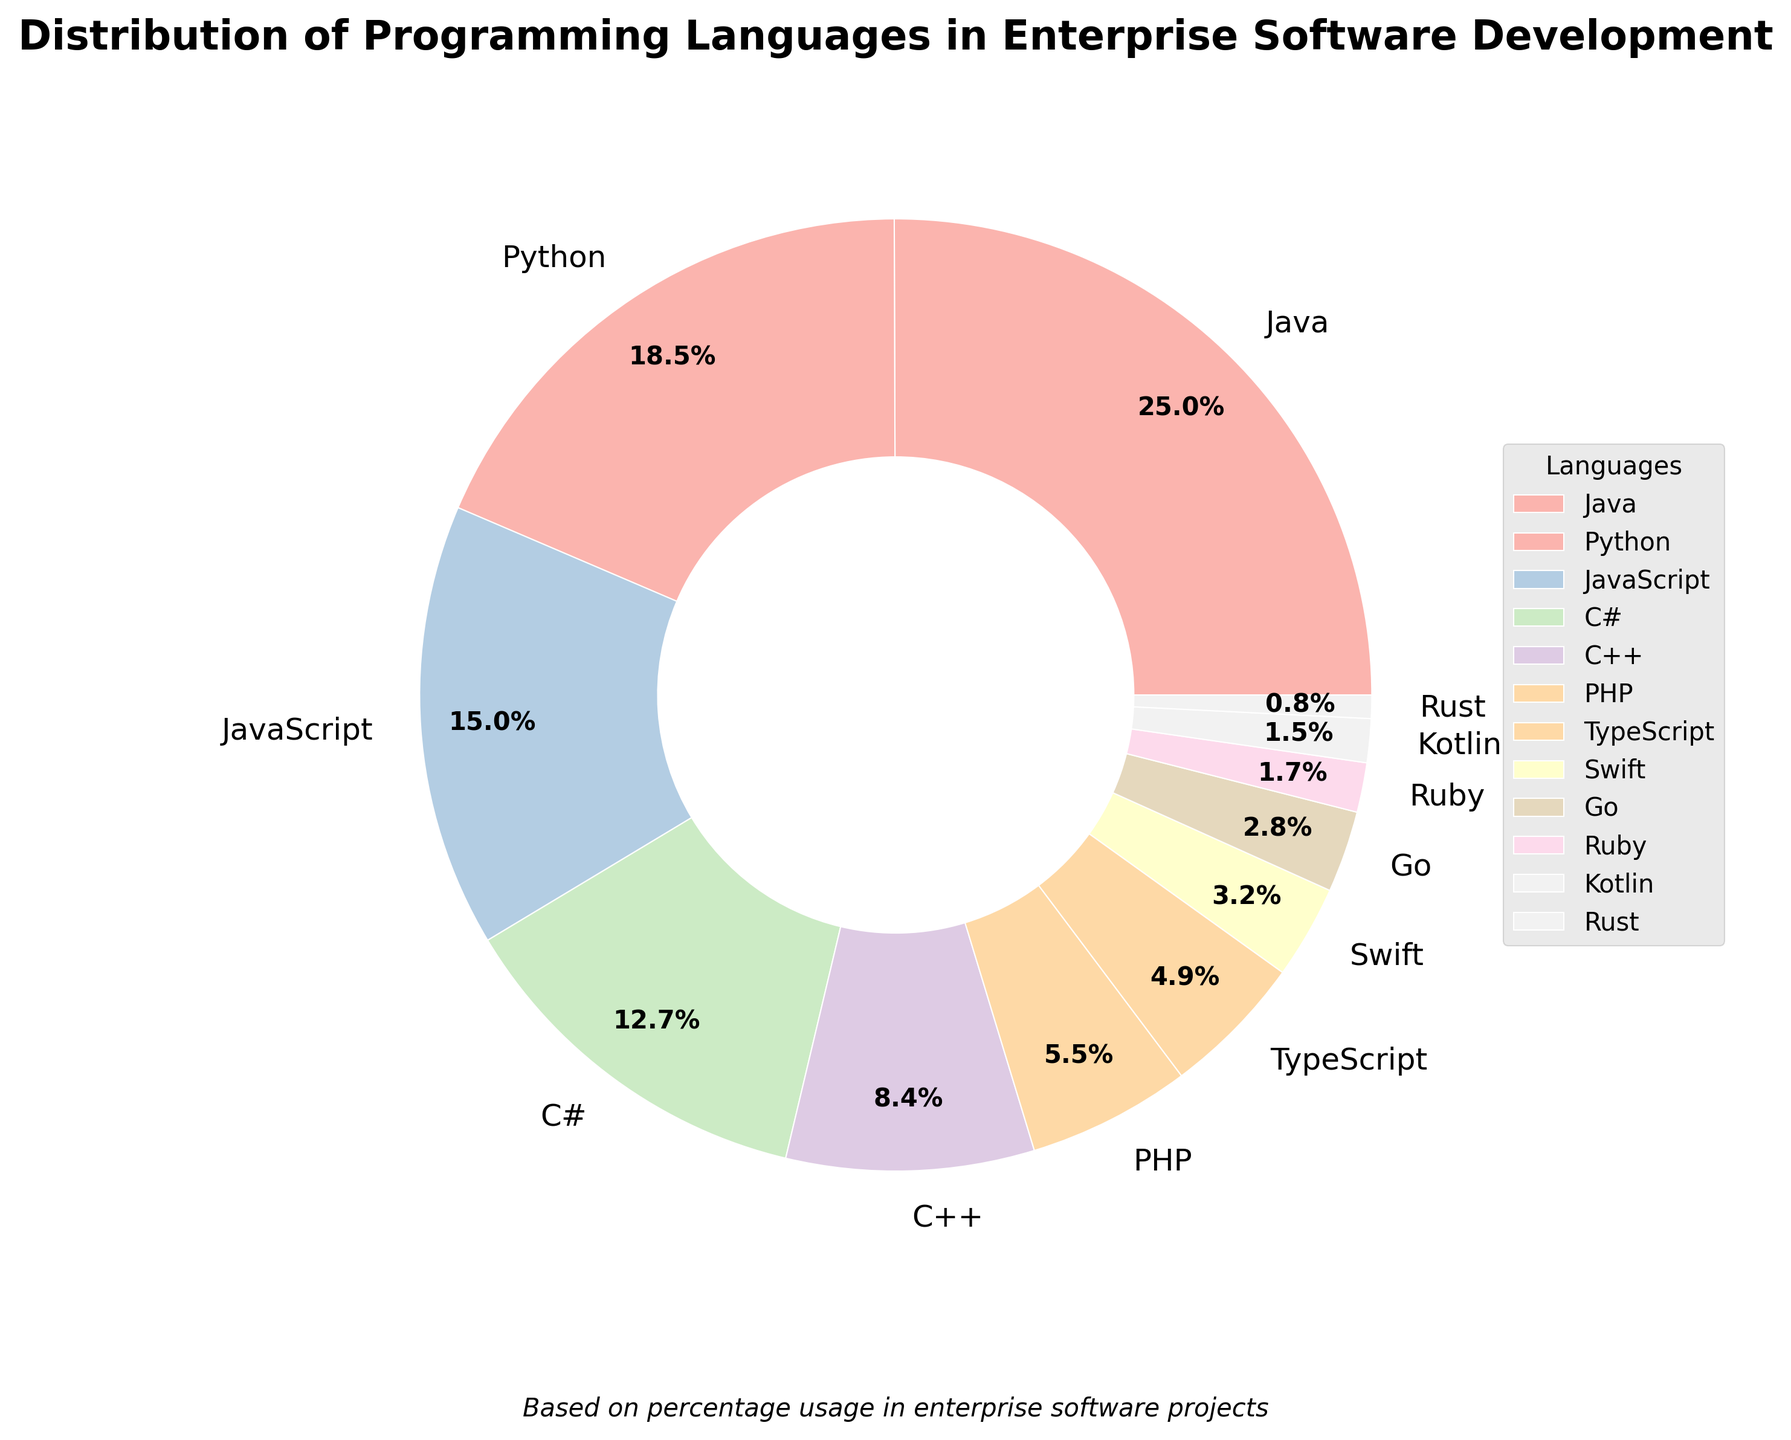Which programming language has the highest usage in enterprise software development based on the pie chart? Java has the highest percentage in the pie chart at 25.3%, thus it is the most used programming language in enterprise software development.
Answer: Java What is the combined percentage usage of Python and JavaScript in enterprise software development? Python has a percentage of 18.7% and JavaScript has 15.2%. Adding these together gives 18.7% + 15.2% = 33.9%.
Answer: 33.9% How much more popular is Java compared to Kotlin based on the pie chart? Java has a percentage of 25.3%, while Kotlin has 1.5%. The difference is 25.3% - 1.5% = 23.8%.
Answer: 23.8% Which two programming languages combined have a higher usage than C# but lower than Java? The percentage for C# is 12.8%. The combined percentages that are higher than 12.8% but less than Java's 25.3% are Python (18.7%) and JavaScript (15.2%), which equal 18.7% + 15.2% = 33.9%.
Answer: Python and JavaScript Among the following programming languages: C#, PHP, and Ruby, which one has the lowest usage in enterprise software development? From the pie chart, C# has 12.8%, PHP has 5.6%, and Ruby has 1.7%. Therefore, Ruby has the lowest usage.
Answer: Ruby If you combine the percentage usage of Swift and Go, what percentage do you get? Swift has a percentage of 3.2% and Go has 2.8%. Combining these gives 3.2% + 2.8% = 6.0%.
Answer: 6.0% Which language has double the percentage usage of Swift in enterprise software development? Looking at the pie chart, Swift has a percentage of 3.2%. The language with double this value is C++ which has 8.5% (approximately double 3.2%).
Answer: C++ Is the percentage usage of PHP greater than, less than, or equal to the combined usage of Kotlin and Rust? The pie chart shows PHP at 5.6%, Kotlin at 1.5%, and Rust at 0.8%. The combined usage of Kotlin and Rust is 1.5% + 0.8% = 2.3%, which is less than PHP's 5.6%.
Answer: Greater than What is the total percentage usage of the six least used programming languages in the pie chart? The six least used languages and their percentages are Kotlin (1.5%), Rust (0.8%), Ruby (1.7%), Go (2.8%), Swift (3.2%), and TypeScript (4.9%). Adding these gives 1.5% + 0.8% + 1.7% + 2.8% + 3.2% + 4.9% = 14.9%.
Answer: 14.9% 